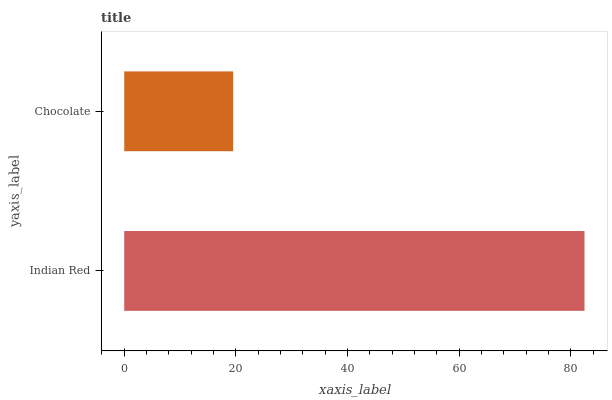Is Chocolate the minimum?
Answer yes or no. Yes. Is Indian Red the maximum?
Answer yes or no. Yes. Is Chocolate the maximum?
Answer yes or no. No. Is Indian Red greater than Chocolate?
Answer yes or no. Yes. Is Chocolate less than Indian Red?
Answer yes or no. Yes. Is Chocolate greater than Indian Red?
Answer yes or no. No. Is Indian Red less than Chocolate?
Answer yes or no. No. Is Indian Red the high median?
Answer yes or no. Yes. Is Chocolate the low median?
Answer yes or no. Yes. Is Chocolate the high median?
Answer yes or no. No. Is Indian Red the low median?
Answer yes or no. No. 